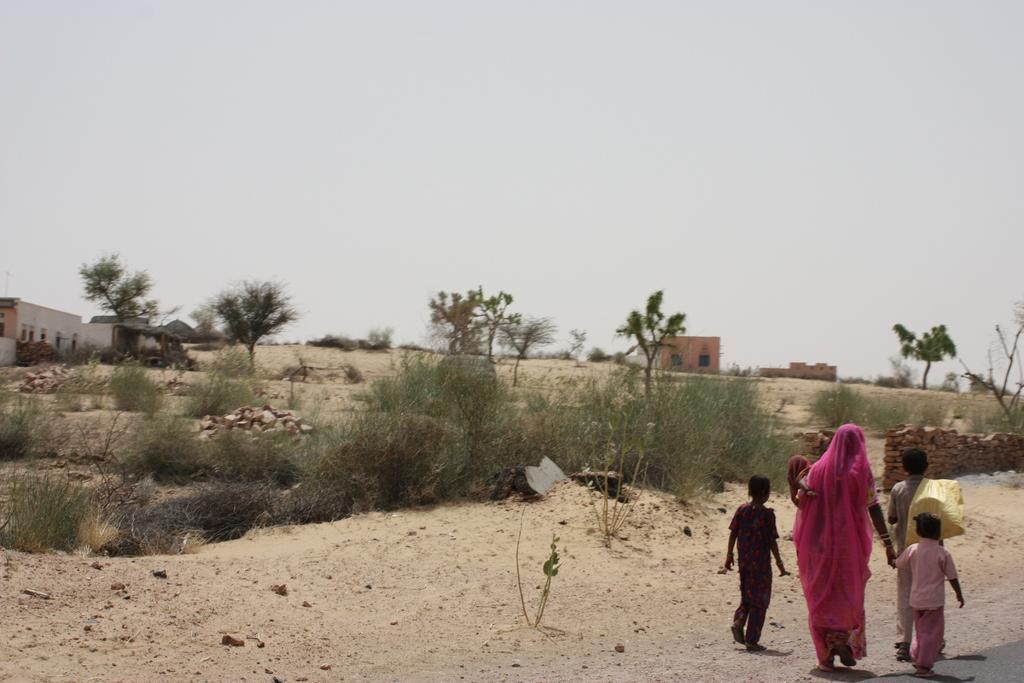Please provide a concise description of this image. In this image, we can see people walking on the road and one of them is holding a bag and we can see a lady holding a kid. In the background, there are trees and plants and we can see sheds and rocks. At the top, there is sky. 